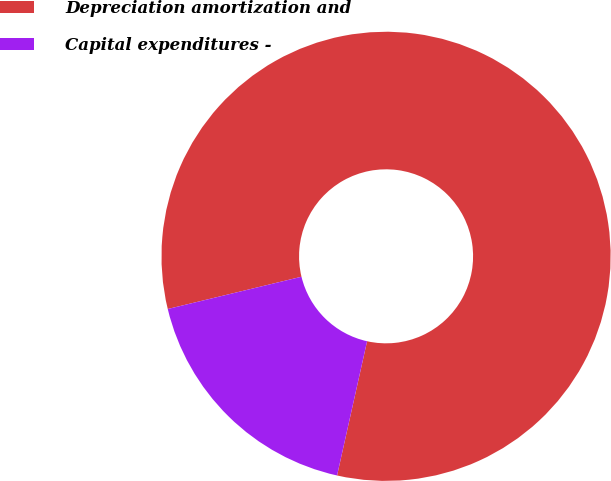<chart> <loc_0><loc_0><loc_500><loc_500><pie_chart><fcel>Depreciation amortization and<fcel>Capital expenditures -<nl><fcel>82.27%<fcel>17.73%<nl></chart> 